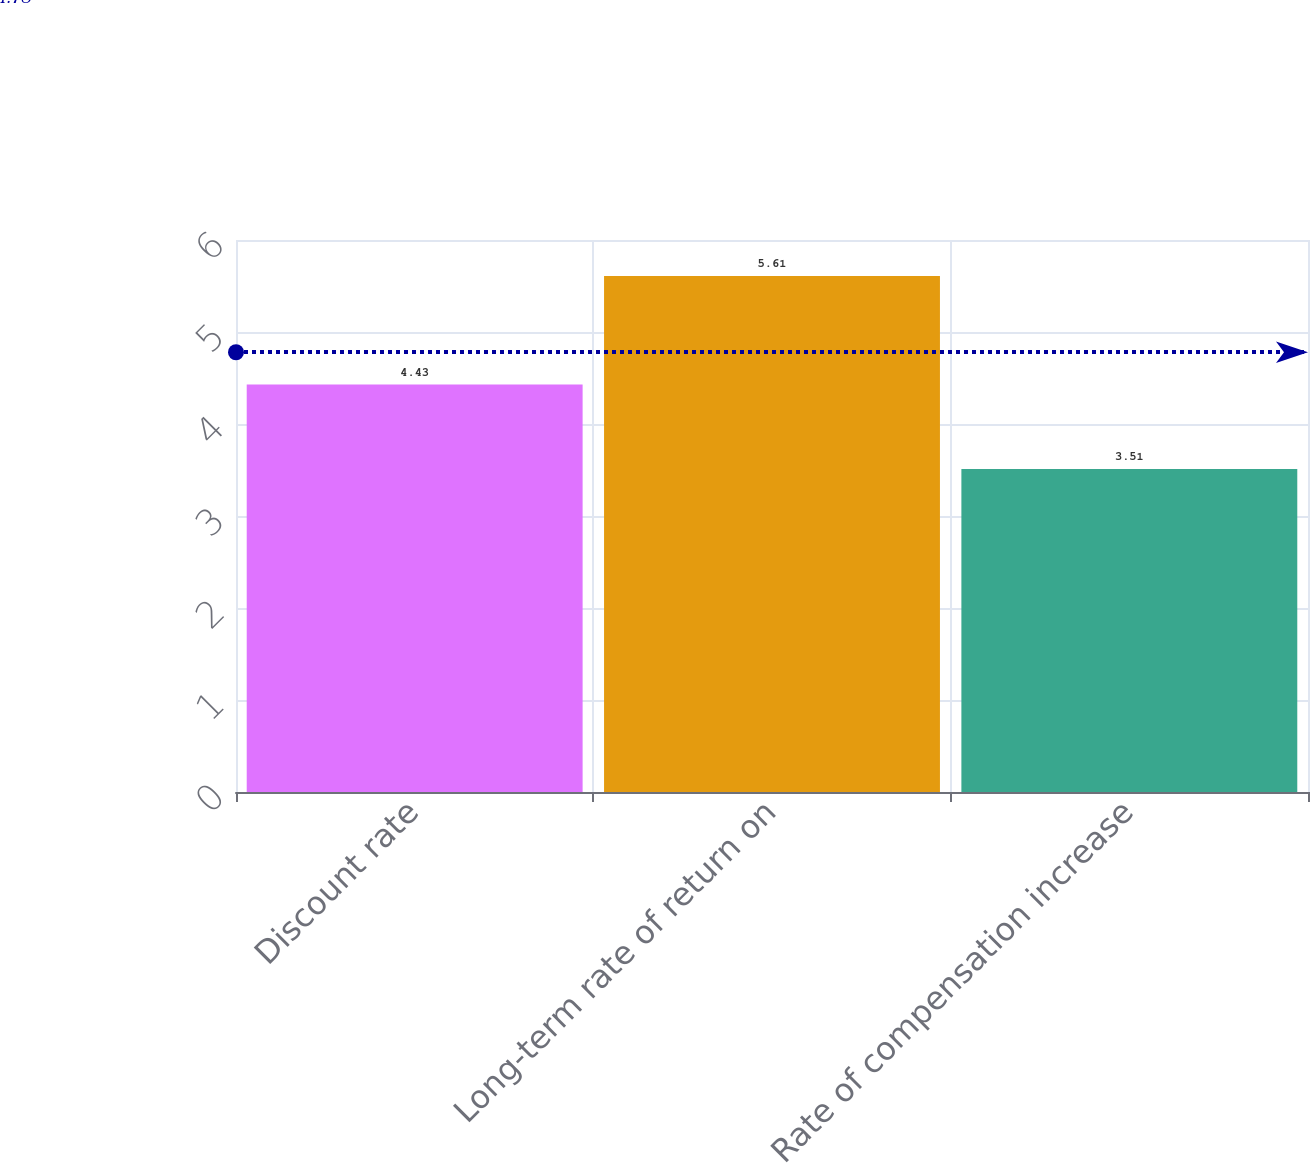Convert chart to OTSL. <chart><loc_0><loc_0><loc_500><loc_500><bar_chart><fcel>Discount rate<fcel>Long-term rate of return on<fcel>Rate of compensation increase<nl><fcel>4.43<fcel>5.61<fcel>3.51<nl></chart> 